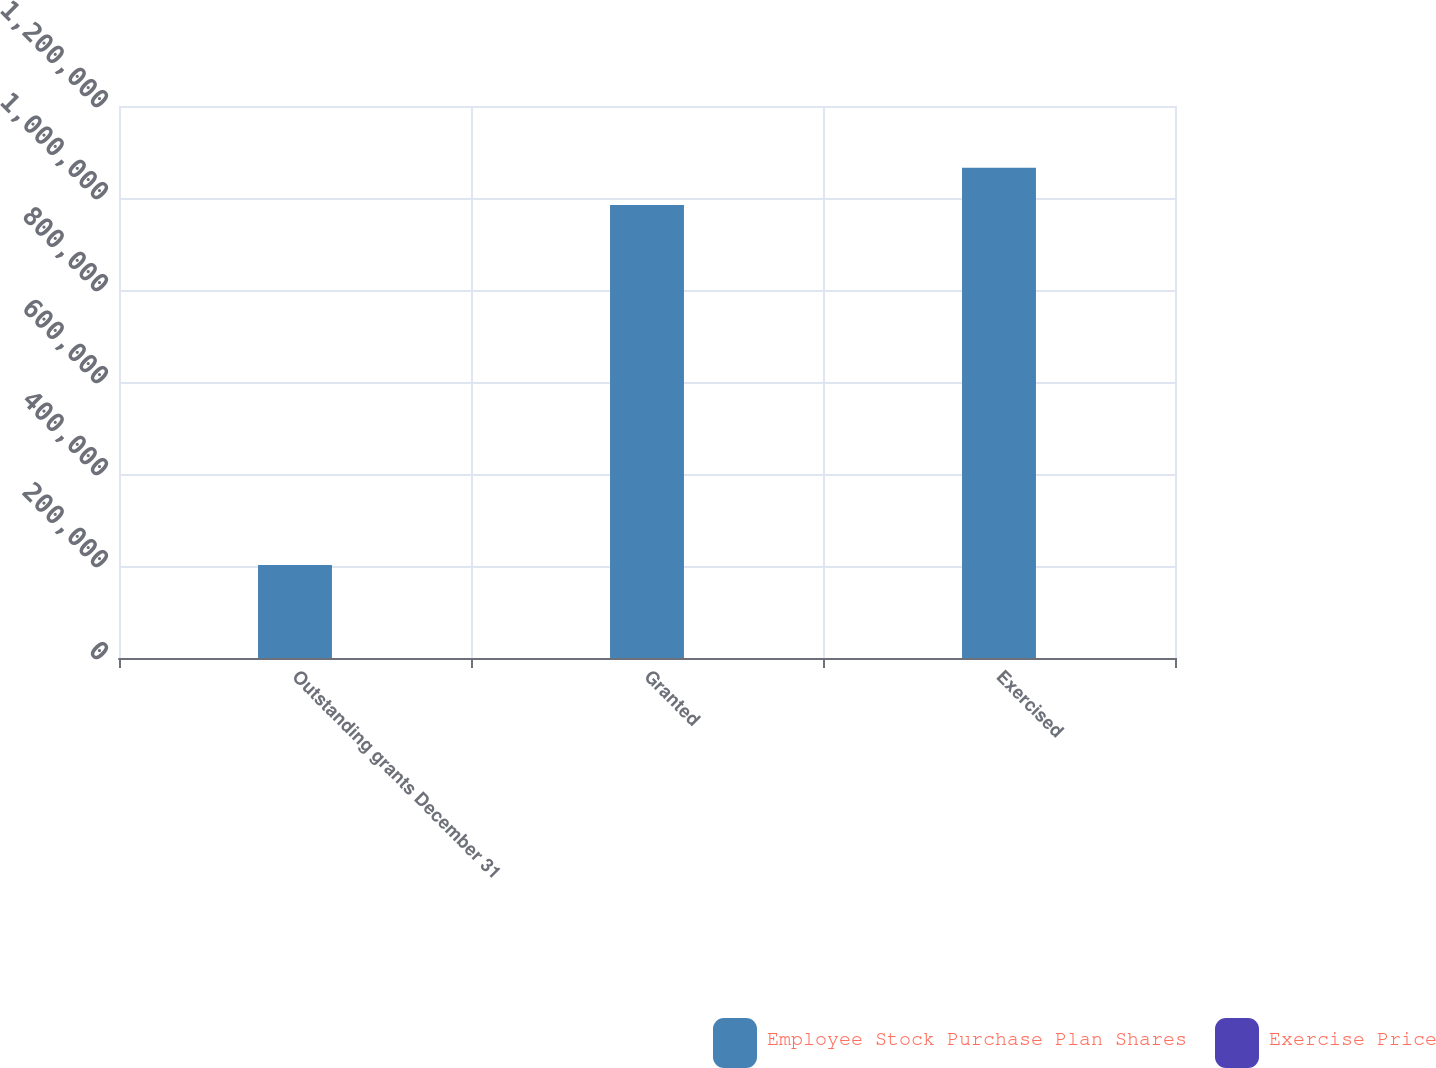<chart> <loc_0><loc_0><loc_500><loc_500><stacked_bar_chart><ecel><fcel>Outstanding grants December 31<fcel>Granted<fcel>Exercised<nl><fcel>Employee Stock Purchase Plan Shares<fcel>202179<fcel>984536<fcel>1.06576e+06<nl><fcel>Exercise Price<fcel>89.74<fcel>55.19<fcel>67.62<nl></chart> 